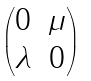<formula> <loc_0><loc_0><loc_500><loc_500>\begin{pmatrix} 0 & \mu \\ \lambda & 0 \end{pmatrix}</formula> 